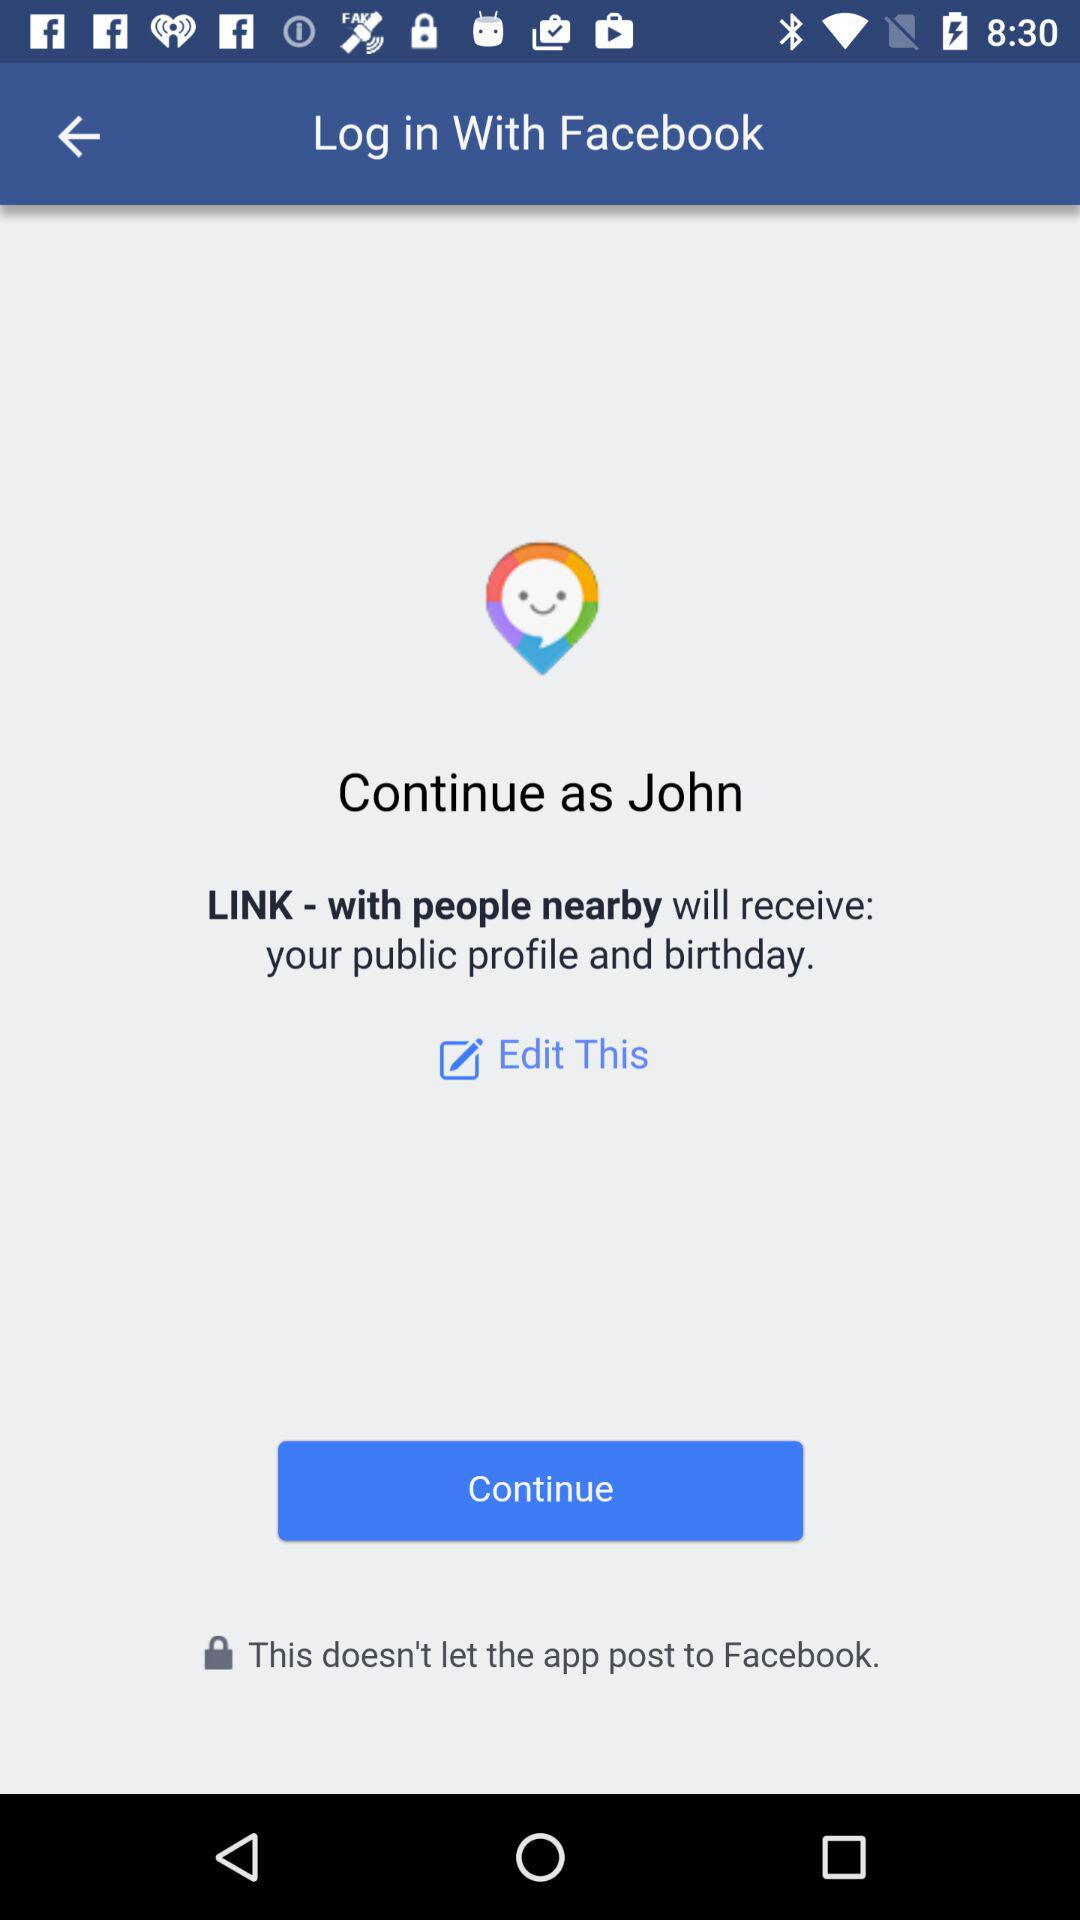What is the login name? The login name is John. 